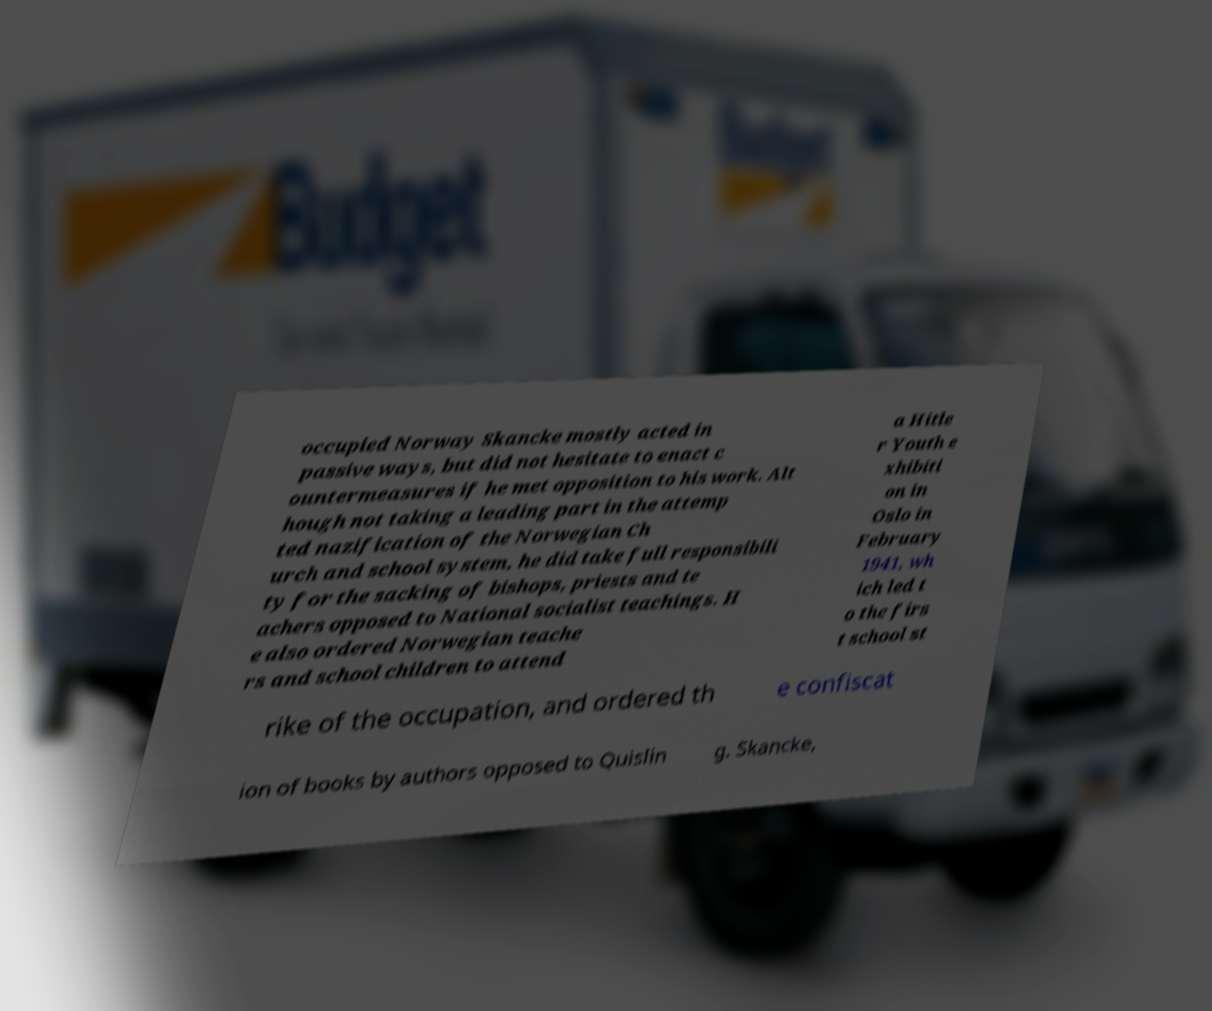Can you read and provide the text displayed in the image?This photo seems to have some interesting text. Can you extract and type it out for me? occupied Norway Skancke mostly acted in passive ways, but did not hesitate to enact c ountermeasures if he met opposition to his work. Alt hough not taking a leading part in the attemp ted nazification of the Norwegian Ch urch and school system, he did take full responsibili ty for the sacking of bishops, priests and te achers opposed to National socialist teachings. H e also ordered Norwegian teache rs and school children to attend a Hitle r Youth e xhibiti on in Oslo in February 1941, wh ich led t o the firs t school st rike of the occupation, and ordered th e confiscat ion of books by authors opposed to Quislin g. Skancke, 